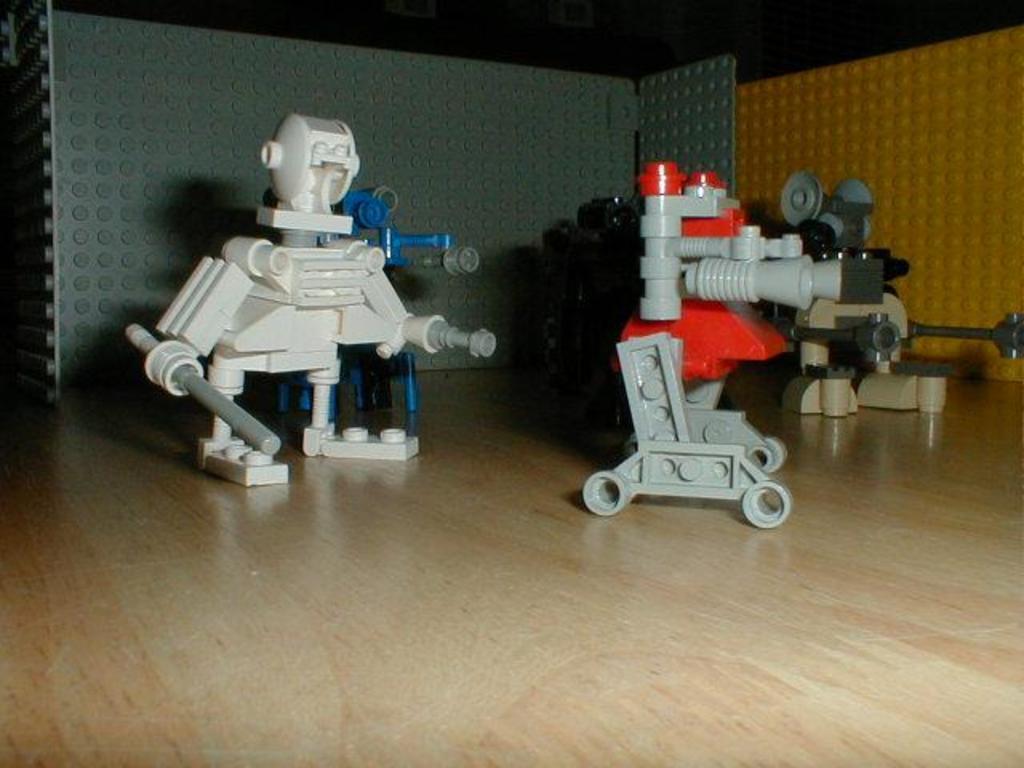How would you summarize this image in a sentence or two? In this picture we can observe toys on the cream color surface. These toys are in white, blue and red colors. We can observe grey and yellow color blocks in the background. 